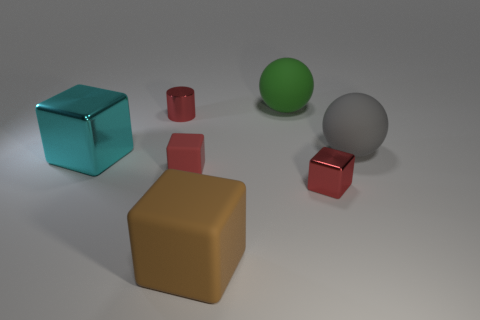Subtract all big brown cubes. How many cubes are left? 3 Subtract all cyan blocks. How many blocks are left? 3 Subtract all balls. How many objects are left? 5 Add 5 big gray matte things. How many big gray matte things exist? 6 Add 1 large yellow metal things. How many objects exist? 8 Subtract 0 yellow cubes. How many objects are left? 7 Subtract 1 balls. How many balls are left? 1 Subtract all gray blocks. Subtract all purple cylinders. How many blocks are left? 4 Subtract all red cubes. How many red spheres are left? 0 Subtract all red matte things. Subtract all green rubber things. How many objects are left? 5 